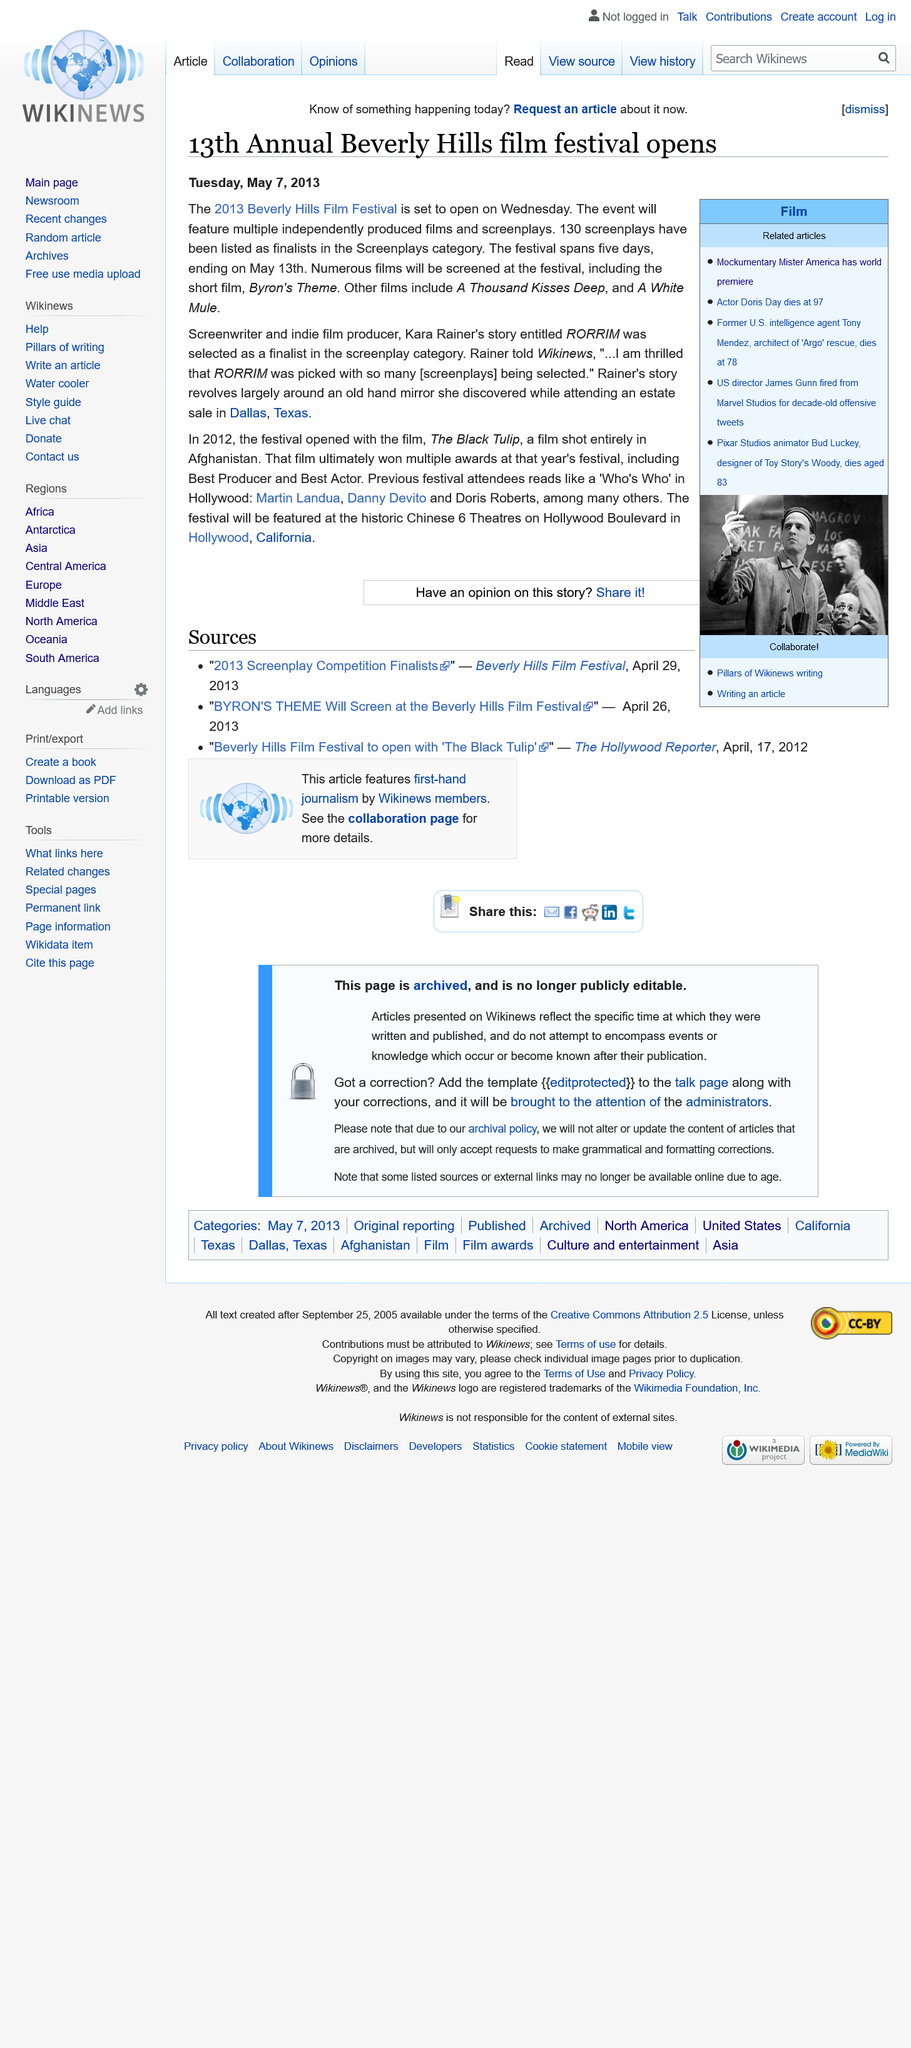Mention a couple of crucial points in this snapshot. The 13th Annual Beverly Hills Film Festival is scheduled to conclude on May 13th. Out of the 130 screenplays that have been listed as finalists in the Screenplays category, 130 screenplays have been listed as finalists in the Screenplays category. Doris Day, a famous actor, died at the age of 97. 